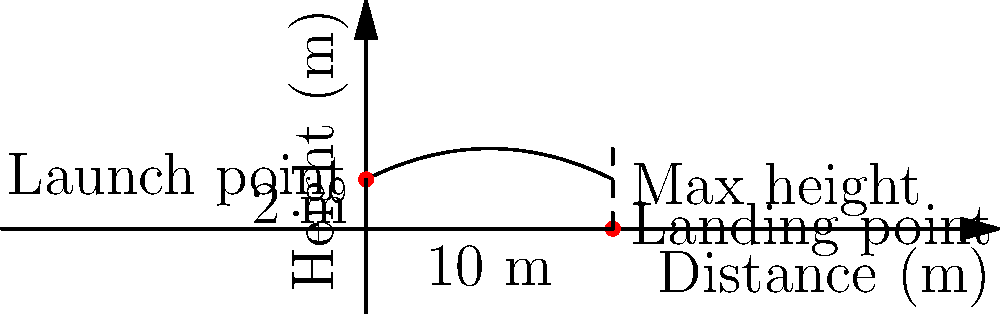During a Valdosta State baseball game, a player hits a home run. The ball's trajectory follows a parabolic path described by the equation $h(x) = -0.05x^2 + 0.5x + 2$, where $h$ is the height in meters and $x$ is the horizontal distance in meters. The ball is hit from a height of 2 meters and lands 10 meters away. What is the maximum height reached by the baseball during its flight? To find the maximum height of the baseball's trajectory, we need to follow these steps:

1) The parabola equation is given as $h(x) = -0.05x^2 + 0.5x + 2$

2) To find the maximum height, we need to find the vertex of the parabola. For a quadratic equation in the form $ax^2 + bx + c$, the x-coordinate of the vertex is given by $x = -\frac{b}{2a}$

3) In our equation, $a = -0.05$ and $b = 0.5$. Let's substitute these values:

   $x = -\frac{0.5}{2(-0.05)} = -\frac{0.5}{-0.1} = 5$ meters

4) Now that we know the x-coordinate of the vertex, we can find the maximum height by plugging this x-value back into our original equation:

   $h(5) = -0.05(5)^2 + 0.5(5) + 2$
         $= -0.05(25) + 2.5 + 2$
         $= -1.25 + 2.5 + 2$
         $= 3.25$ meters

Therefore, the maximum height reached by the baseball is 3.25 meters.
Answer: 3.25 meters 